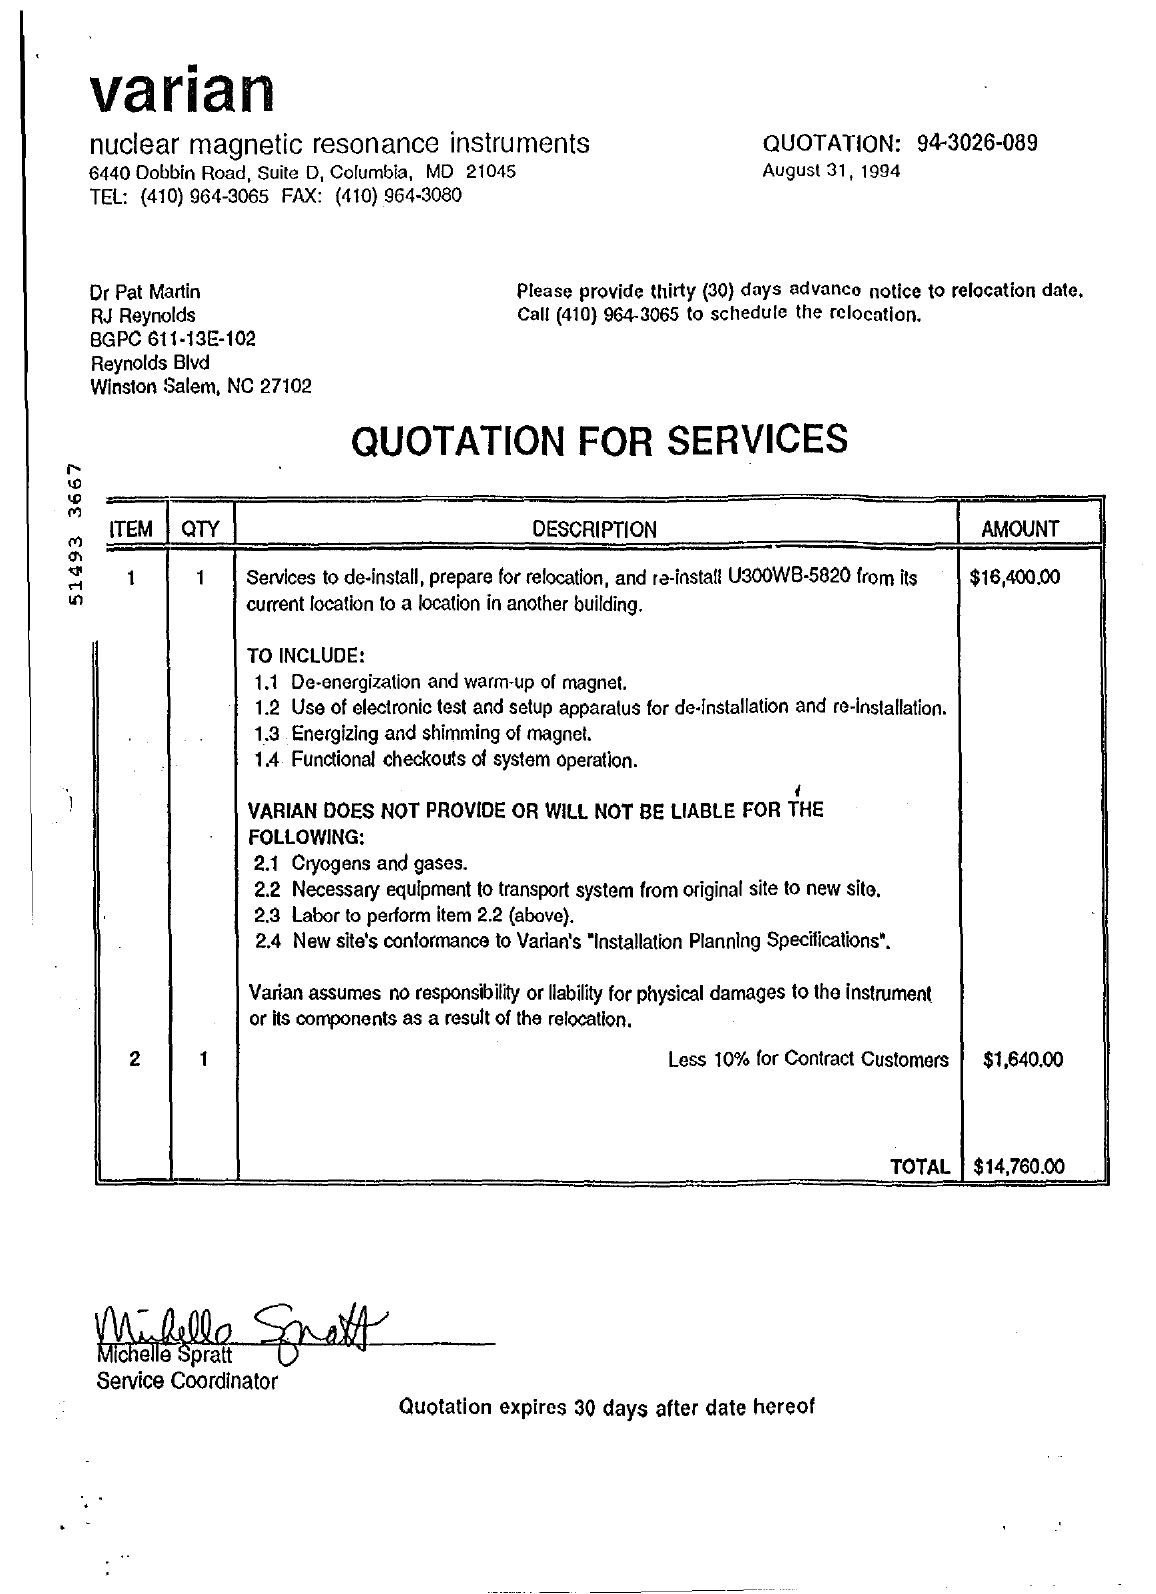What's the total cost for relocation?
Your answer should be compact. $14,760.00. 